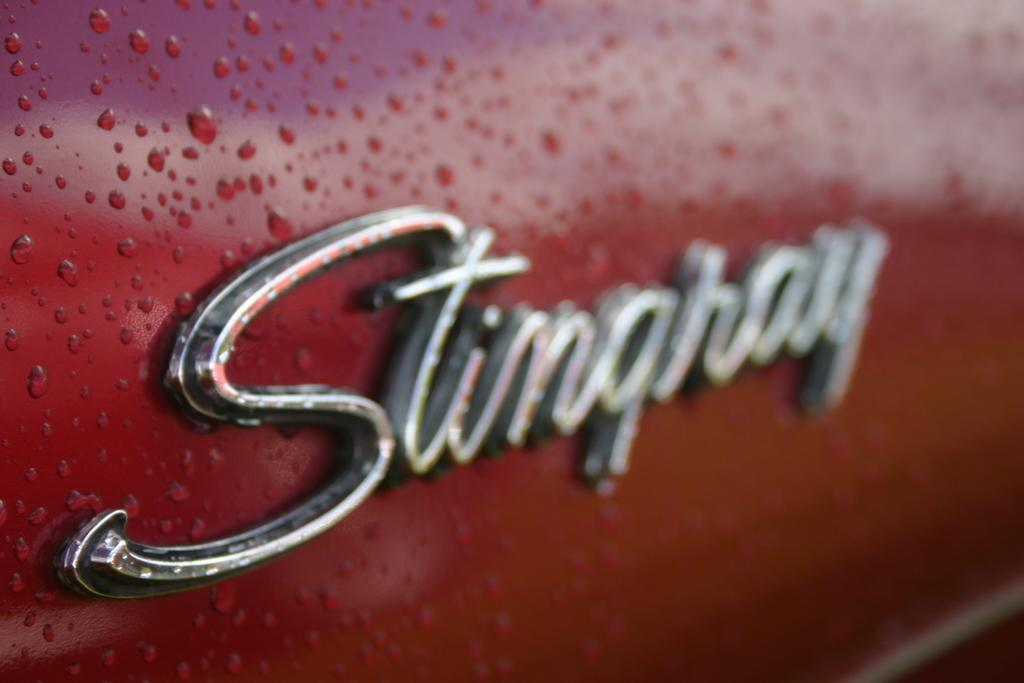What is the main subject in the center of the image? There is a name in the center of the image. Where is the name located? The name is on a car. What color is the car? The car is red in color. How does the car emit a cough in the image? The car does not emit a cough in the image; it is a static image with no sound or movement. 